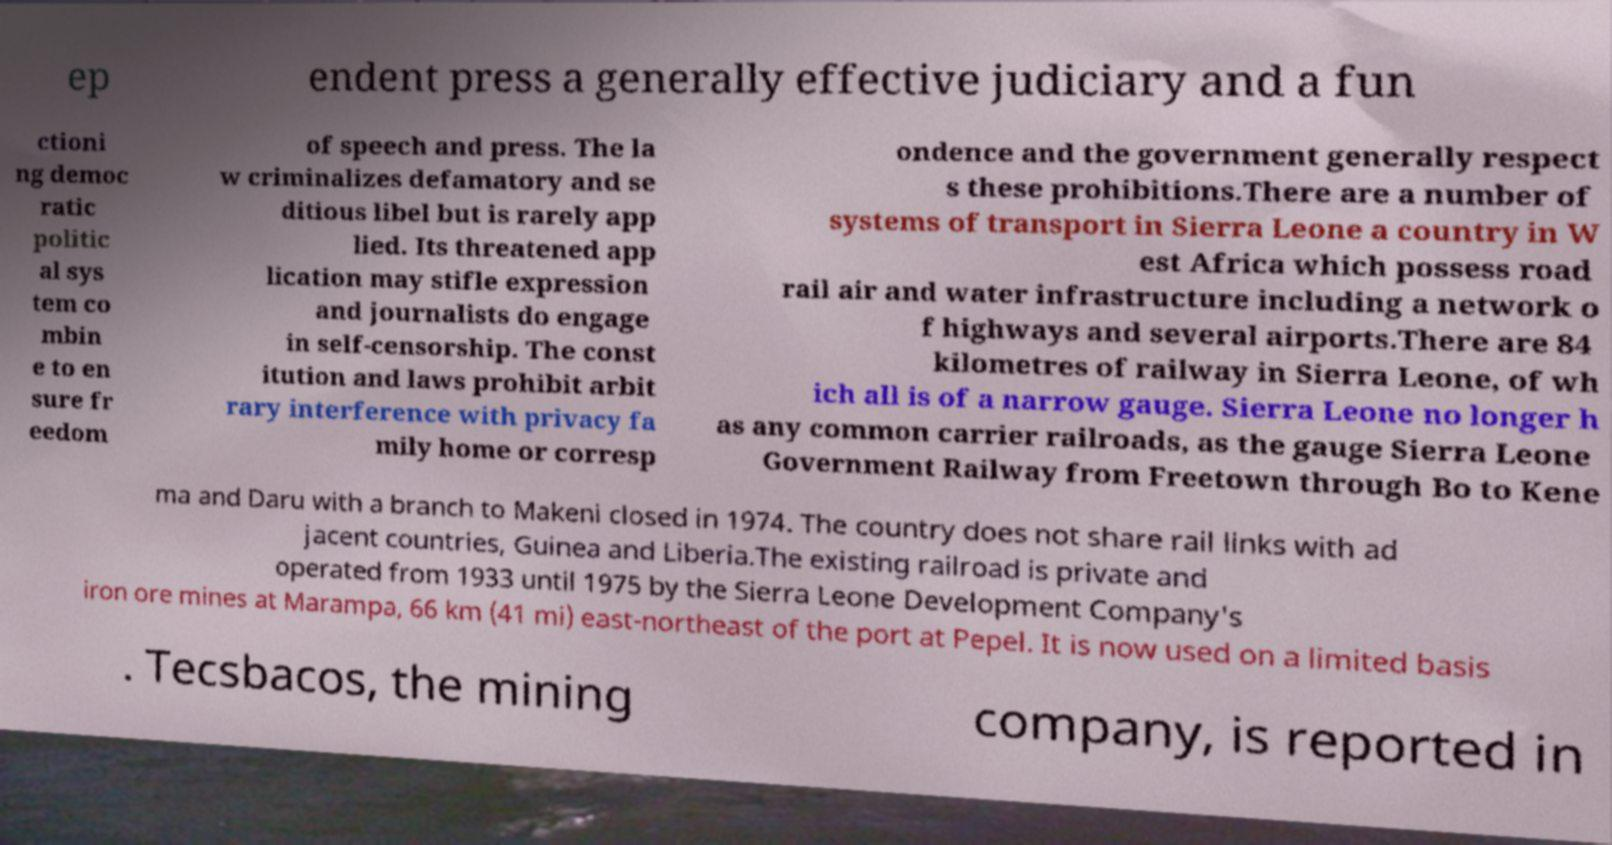Could you assist in decoding the text presented in this image and type it out clearly? ep endent press a generally effective judiciary and a fun ctioni ng democ ratic politic al sys tem co mbin e to en sure fr eedom of speech and press. The la w criminalizes defamatory and se ditious libel but is rarely app lied. Its threatened app lication may stifle expression and journalists do engage in self-censorship. The const itution and laws prohibit arbit rary interference with privacy fa mily home or corresp ondence and the government generally respect s these prohibitions.There are a number of systems of transport in Sierra Leone a country in W est Africa which possess road rail air and water infrastructure including a network o f highways and several airports.There are 84 kilometres of railway in Sierra Leone, of wh ich all is of a narrow gauge. Sierra Leone no longer h as any common carrier railroads, as the gauge Sierra Leone Government Railway from Freetown through Bo to Kene ma and Daru with a branch to Makeni closed in 1974. The country does not share rail links with ad jacent countries, Guinea and Liberia.The existing railroad is private and operated from 1933 until 1975 by the Sierra Leone Development Company's iron ore mines at Marampa, 66 km (41 mi) east-northeast of the port at Pepel. It is now used on a limited basis . Tecsbacos, the mining company, is reported in 